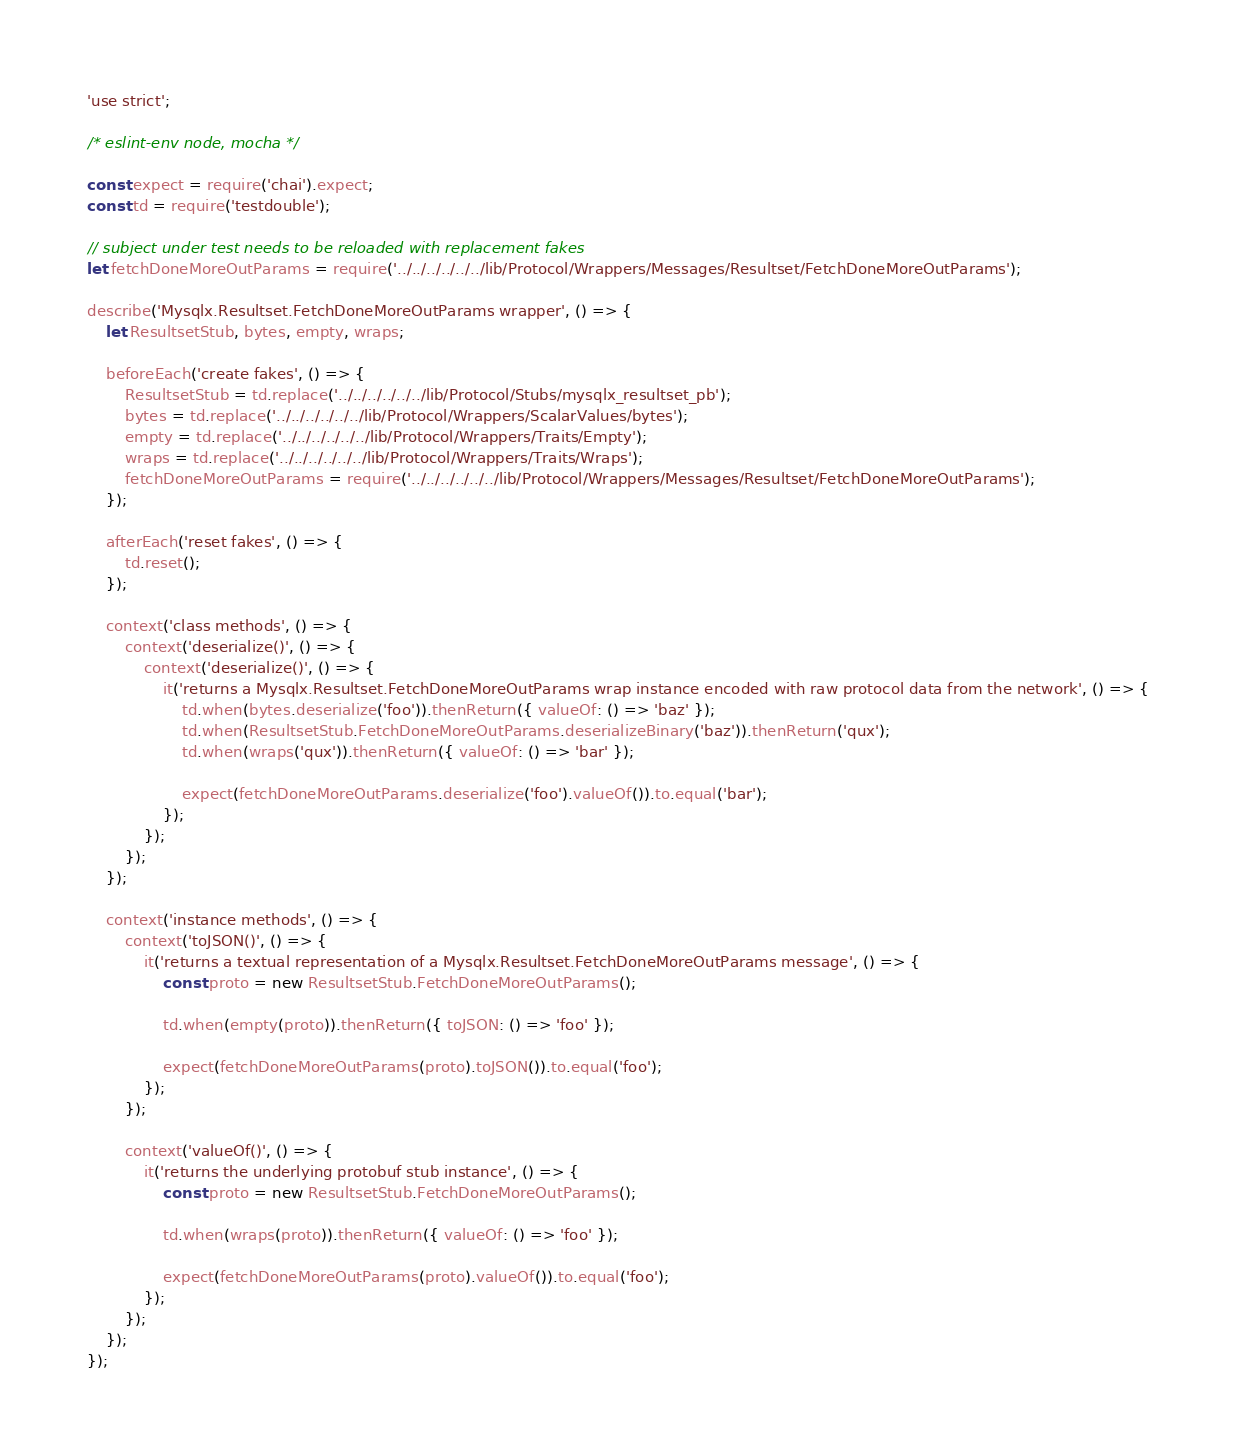<code> <loc_0><loc_0><loc_500><loc_500><_JavaScript_>'use strict';

/* eslint-env node, mocha */

const expect = require('chai').expect;
const td = require('testdouble');

// subject under test needs to be reloaded with replacement fakes
let fetchDoneMoreOutParams = require('../../../../../../lib/Protocol/Wrappers/Messages/Resultset/FetchDoneMoreOutParams');

describe('Mysqlx.Resultset.FetchDoneMoreOutParams wrapper', () => {
    let ResultsetStub, bytes, empty, wraps;

    beforeEach('create fakes', () => {
        ResultsetStub = td.replace('../../../../../../lib/Protocol/Stubs/mysqlx_resultset_pb');
        bytes = td.replace('../../../../../../lib/Protocol/Wrappers/ScalarValues/bytes');
        empty = td.replace('../../../../../../lib/Protocol/Wrappers/Traits/Empty');
        wraps = td.replace('../../../../../../lib/Protocol/Wrappers/Traits/Wraps');
        fetchDoneMoreOutParams = require('../../../../../../lib/Protocol/Wrappers/Messages/Resultset/FetchDoneMoreOutParams');
    });

    afterEach('reset fakes', () => {
        td.reset();
    });

    context('class methods', () => {
        context('deserialize()', () => {
            context('deserialize()', () => {
                it('returns a Mysqlx.Resultset.FetchDoneMoreOutParams wrap instance encoded with raw protocol data from the network', () => {
                    td.when(bytes.deserialize('foo')).thenReturn({ valueOf: () => 'baz' });
                    td.when(ResultsetStub.FetchDoneMoreOutParams.deserializeBinary('baz')).thenReturn('qux');
                    td.when(wraps('qux')).thenReturn({ valueOf: () => 'bar' });

                    expect(fetchDoneMoreOutParams.deserialize('foo').valueOf()).to.equal('bar');
                });
            });
        });
    });

    context('instance methods', () => {
        context('toJSON()', () => {
            it('returns a textual representation of a Mysqlx.Resultset.FetchDoneMoreOutParams message', () => {
                const proto = new ResultsetStub.FetchDoneMoreOutParams();

                td.when(empty(proto)).thenReturn({ toJSON: () => 'foo' });

                expect(fetchDoneMoreOutParams(proto).toJSON()).to.equal('foo');
            });
        });

        context('valueOf()', () => {
            it('returns the underlying protobuf stub instance', () => {
                const proto = new ResultsetStub.FetchDoneMoreOutParams();

                td.when(wraps(proto)).thenReturn({ valueOf: () => 'foo' });

                expect(fetchDoneMoreOutParams(proto).valueOf()).to.equal('foo');
            });
        });
    });
});
</code> 